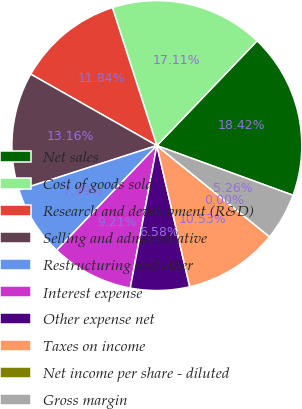Convert chart. <chart><loc_0><loc_0><loc_500><loc_500><pie_chart><fcel>Net sales<fcel>Cost of goods sold<fcel>Research and development (R&D)<fcel>Selling and administrative<fcel>Restructuring and other<fcel>Interest expense<fcel>Other expense net<fcel>Taxes on income<fcel>Net income per share - diluted<fcel>Gross margin<nl><fcel>18.42%<fcel>17.11%<fcel>11.84%<fcel>13.16%<fcel>7.89%<fcel>9.21%<fcel>6.58%<fcel>10.53%<fcel>0.0%<fcel>5.26%<nl></chart> 